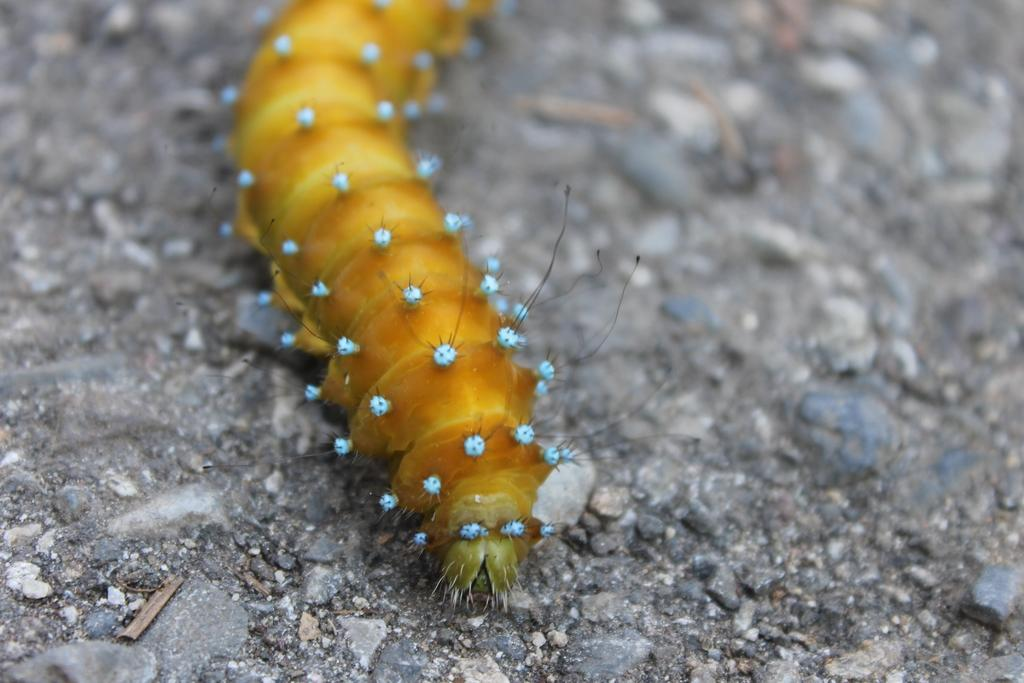What is the main subject in the center of the image? There is a worm in the center of the image. What other objects can be seen in the image? There are stones in the image. What type of floor can be seen in the image? There is no floor visible in the image; it only contains a worm and stones. 